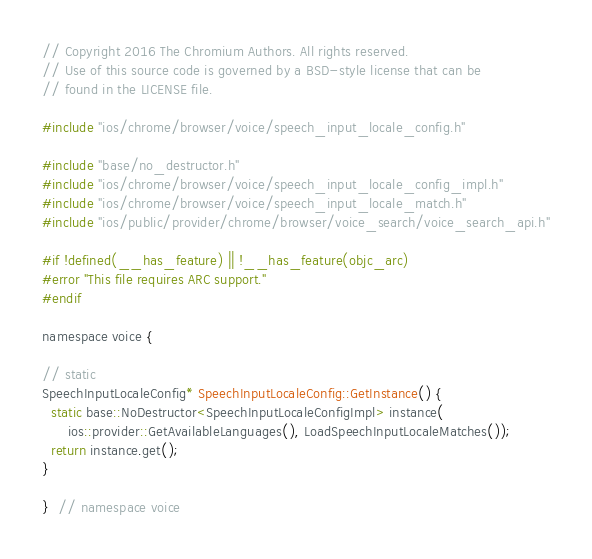Convert code to text. <code><loc_0><loc_0><loc_500><loc_500><_ObjectiveC_>// Copyright 2016 The Chromium Authors. All rights reserved.
// Use of this source code is governed by a BSD-style license that can be
// found in the LICENSE file.

#include "ios/chrome/browser/voice/speech_input_locale_config.h"

#include "base/no_destructor.h"
#include "ios/chrome/browser/voice/speech_input_locale_config_impl.h"
#include "ios/chrome/browser/voice/speech_input_locale_match.h"
#include "ios/public/provider/chrome/browser/voice_search/voice_search_api.h"

#if !defined(__has_feature) || !__has_feature(objc_arc)
#error "This file requires ARC support."
#endif

namespace voice {

// static
SpeechInputLocaleConfig* SpeechInputLocaleConfig::GetInstance() {
  static base::NoDestructor<SpeechInputLocaleConfigImpl> instance(
      ios::provider::GetAvailableLanguages(), LoadSpeechInputLocaleMatches());
  return instance.get();
}

}  // namespace voice
</code> 